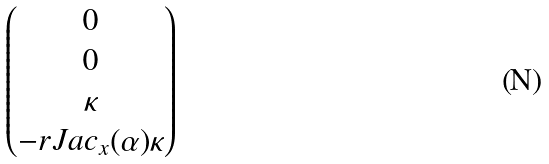<formula> <loc_0><loc_0><loc_500><loc_500>\begin{pmatrix} 0 \\ 0 \\ \kappa \\ - r J a c _ { x } ( \alpha ) \kappa \end{pmatrix}</formula> 